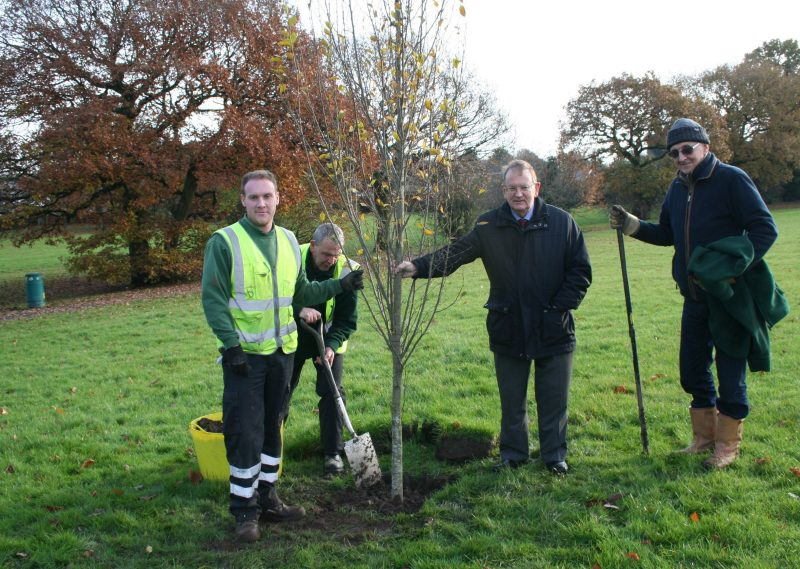Considering the tools and the number of people involved, what might be the extent and nature of the tree planting project in which these individuals are participating? Based on the image, the tree planting project appears to be a small to medium-scale community or local government effort. The group includes a few individuals using basic hand tools, planting a single tree. This suggests that the initiative is more likely focused on environmental enhancement or community beautification rather than a large-scale commercial project. The presence of an older individual in more formal attire might indicate a supervisory or ceremonial role, hinting at the project's significance to the local community. This activity could be part of a local environmental awareness day, a neighborhood improvement project, or a civic effort to enhance green spaces. 